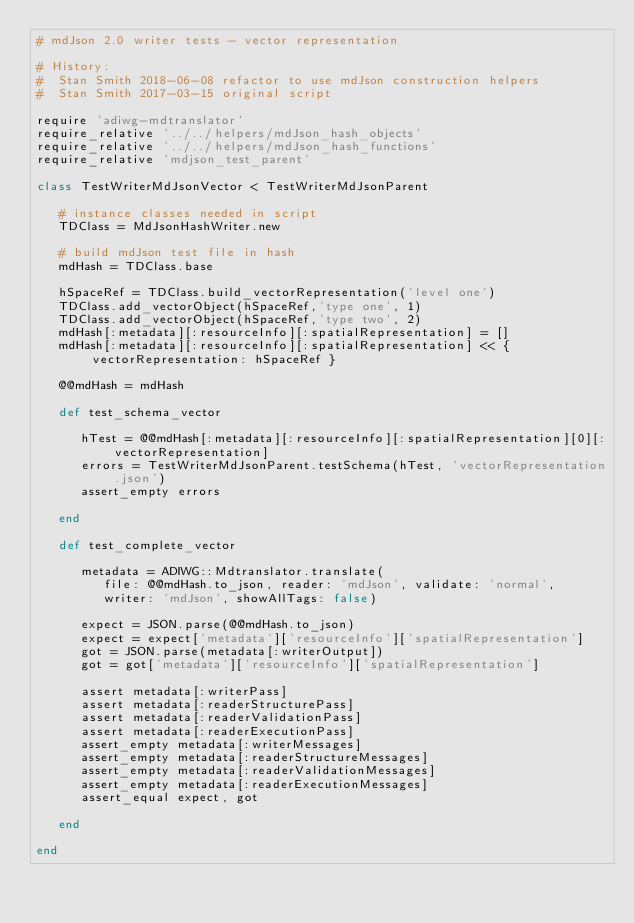Convert code to text. <code><loc_0><loc_0><loc_500><loc_500><_Ruby_># mdJson 2.0 writer tests - vector representation

# History:
#  Stan Smith 2018-06-08 refactor to use mdJson construction helpers
#  Stan Smith 2017-03-15 original script

require 'adiwg-mdtranslator'
require_relative '../../helpers/mdJson_hash_objects'
require_relative '../../helpers/mdJson_hash_functions'
require_relative 'mdjson_test_parent'

class TestWriterMdJsonVector < TestWriterMdJsonParent

   # instance classes needed in script
   TDClass = MdJsonHashWriter.new

   # build mdJson test file in hash
   mdHash = TDClass.base

   hSpaceRef = TDClass.build_vectorRepresentation('level one')
   TDClass.add_vectorObject(hSpaceRef,'type one', 1)
   TDClass.add_vectorObject(hSpaceRef,'type two', 2)
   mdHash[:metadata][:resourceInfo][:spatialRepresentation] = []
   mdHash[:metadata][:resourceInfo][:spatialRepresentation] << { vectorRepresentation: hSpaceRef }

   @@mdHash = mdHash

   def test_schema_vector

      hTest = @@mdHash[:metadata][:resourceInfo][:spatialRepresentation][0][:vectorRepresentation]
      errors = TestWriterMdJsonParent.testSchema(hTest, 'vectorRepresentation.json')
      assert_empty errors

   end

   def test_complete_vector

      metadata = ADIWG::Mdtranslator.translate(
         file: @@mdHash.to_json, reader: 'mdJson', validate: 'normal',
         writer: 'mdJson', showAllTags: false)

      expect = JSON.parse(@@mdHash.to_json)
      expect = expect['metadata']['resourceInfo']['spatialRepresentation']
      got = JSON.parse(metadata[:writerOutput])
      got = got['metadata']['resourceInfo']['spatialRepresentation']

      assert metadata[:writerPass]
      assert metadata[:readerStructurePass]
      assert metadata[:readerValidationPass]
      assert metadata[:readerExecutionPass]
      assert_empty metadata[:writerMessages]
      assert_empty metadata[:readerStructureMessages]
      assert_empty metadata[:readerValidationMessages]
      assert_empty metadata[:readerExecutionMessages]
      assert_equal expect, got

   end

end
</code> 